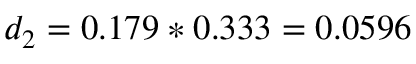Convert formula to latex. <formula><loc_0><loc_0><loc_500><loc_500>d _ { 2 } = 0 . 1 7 9 * 0 . 3 3 3 = 0 . 0 5 9 6</formula> 